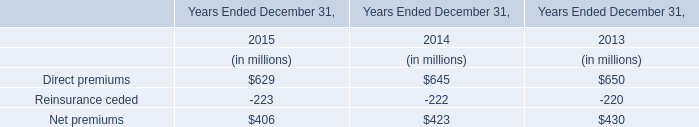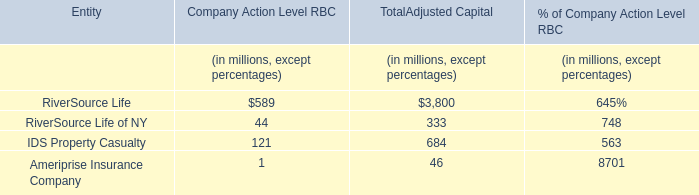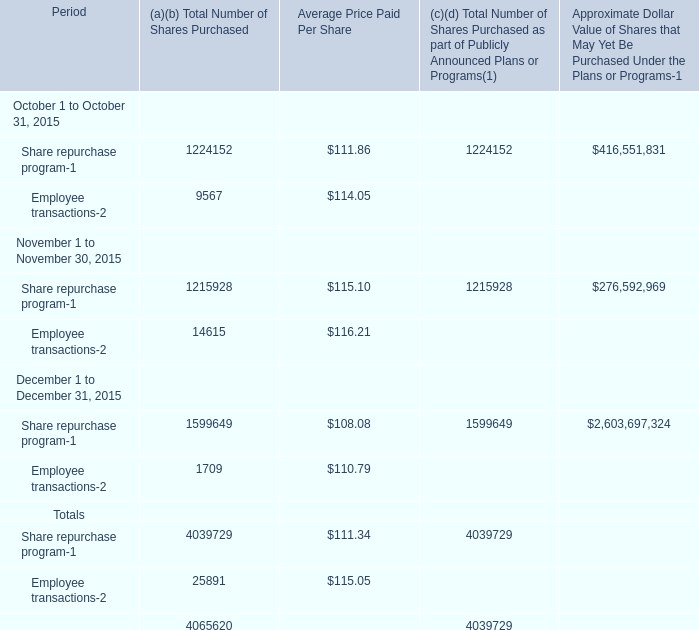What month in the Fourth Quarter is Total Number of Shares Purchased for Share repurchase program the most? 
Answer: 12. 